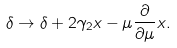Convert formula to latex. <formula><loc_0><loc_0><loc_500><loc_500>\delta \rightarrow \delta + 2 \gamma _ { 2 } x - \mu \frac { \partial } { \partial \mu } x .</formula> 